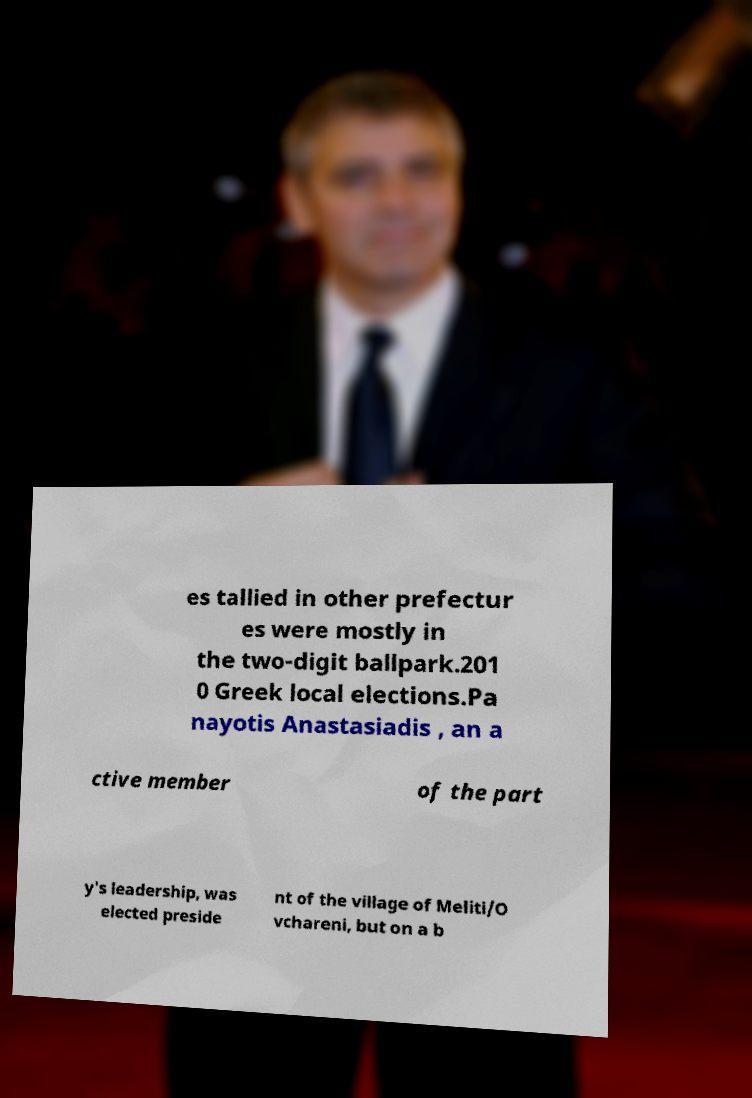For documentation purposes, I need the text within this image transcribed. Could you provide that? es tallied in other prefectur es were mostly in the two-digit ballpark.201 0 Greek local elections.Pa nayotis Anastasiadis , an a ctive member of the part y's leadership, was elected preside nt of the village of Meliti/O vchareni, but on a b 